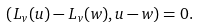<formula> <loc_0><loc_0><loc_500><loc_500>( L _ { v } ( u ) - L _ { v } ( w ) , u - w ) = 0 .</formula> 